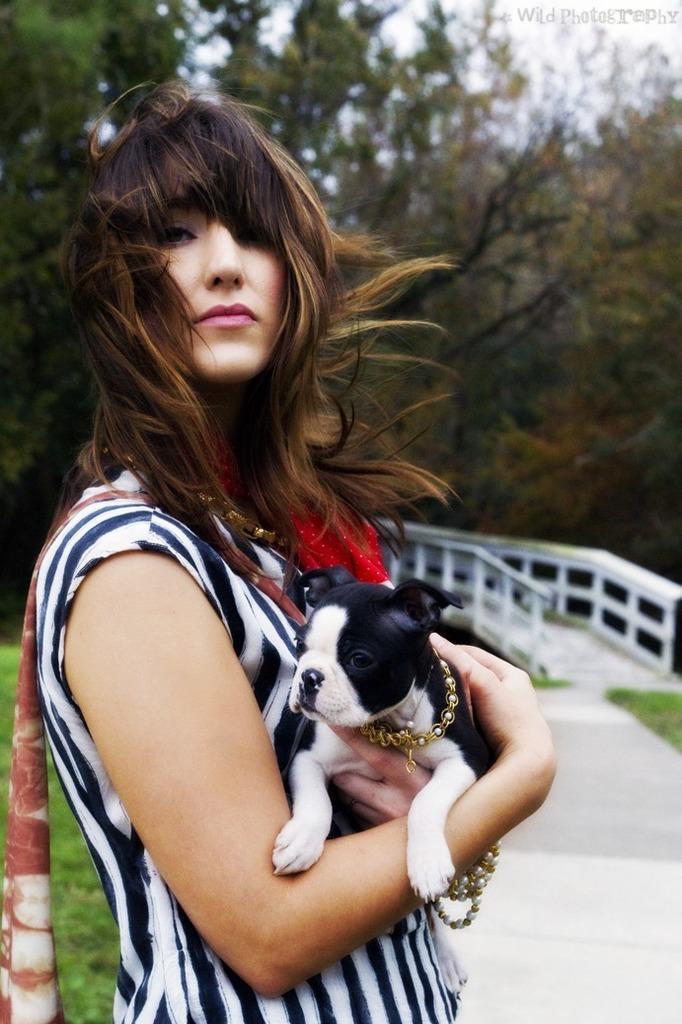Could you give a brief overview of what you see in this image? This person standing and holding dog. We can see trees. 